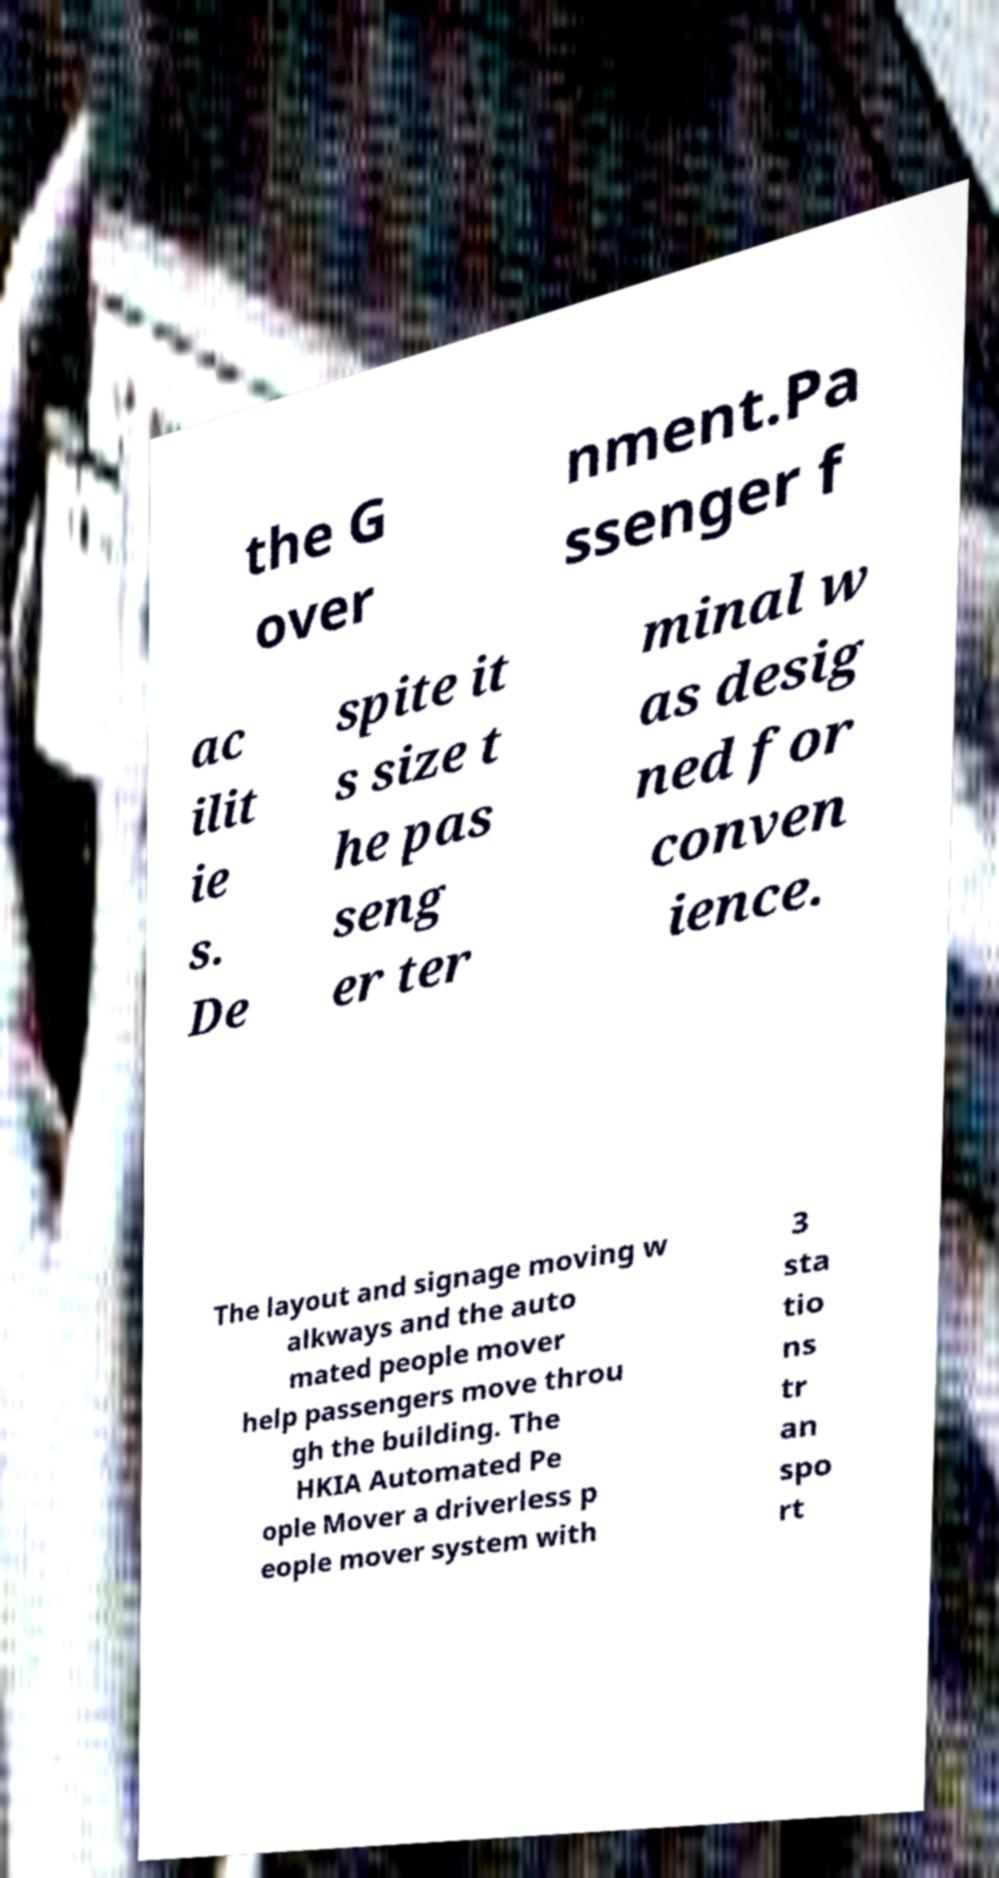Please identify and transcribe the text found in this image. the G over nment.Pa ssenger f ac ilit ie s. De spite it s size t he pas seng er ter minal w as desig ned for conven ience. The layout and signage moving w alkways and the auto mated people mover help passengers move throu gh the building. The HKIA Automated Pe ople Mover a driverless p eople mover system with 3 sta tio ns tr an spo rt 